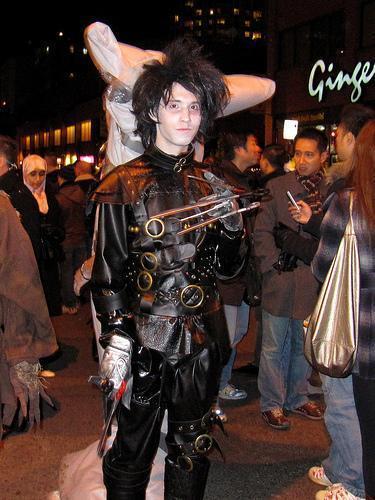How many people are in costume?
Give a very brief answer. 1. 